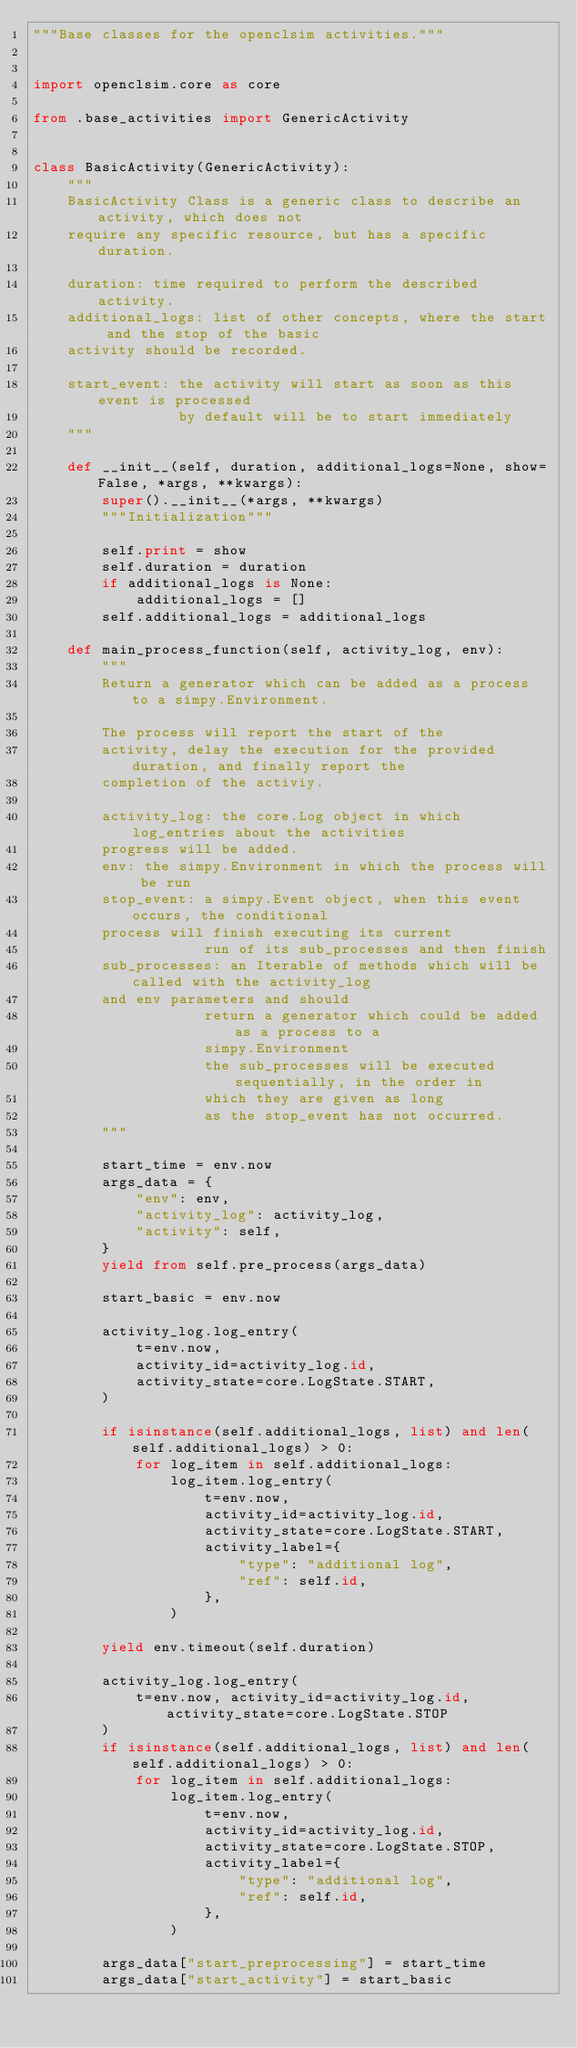Convert code to text. <code><loc_0><loc_0><loc_500><loc_500><_Python_>"""Base classes for the openclsim activities."""


import openclsim.core as core

from .base_activities import GenericActivity


class BasicActivity(GenericActivity):
    """
    BasicActivity Class is a generic class to describe an activity, which does not
    require any specific resource, but has a specific duration.

    duration: time required to perform the described activity.
    additional_logs: list of other concepts, where the start and the stop of the basic
    activity should be recorded.

    start_event: the activity will start as soon as this event is processed
                 by default will be to start immediately
    """

    def __init__(self, duration, additional_logs=None, show=False, *args, **kwargs):
        super().__init__(*args, **kwargs)
        """Initialization"""

        self.print = show
        self.duration = duration
        if additional_logs is None:
            additional_logs = []
        self.additional_logs = additional_logs

    def main_process_function(self, activity_log, env):
        """
        Return a generator which can be added as a process to a simpy.Environment.

        The process will report the start of the
        activity, delay the execution for the provided duration, and finally report the
        completion of the activiy.

        activity_log: the core.Log object in which log_entries about the activities
        progress will be added.
        env: the simpy.Environment in which the process will be run
        stop_event: a simpy.Event object, when this event occurs, the conditional
        process will finish executing its current
                    run of its sub_processes and then finish
        sub_processes: an Iterable of methods which will be called with the activity_log
        and env parameters and should
                    return a generator which could be added as a process to a
                    simpy.Environment
                    the sub_processes will be executed sequentially, in the order in
                    which they are given as long
                    as the stop_event has not occurred.
        """

        start_time = env.now
        args_data = {
            "env": env,
            "activity_log": activity_log,
            "activity": self,
        }
        yield from self.pre_process(args_data)

        start_basic = env.now

        activity_log.log_entry(
            t=env.now,
            activity_id=activity_log.id,
            activity_state=core.LogState.START,
        )

        if isinstance(self.additional_logs, list) and len(self.additional_logs) > 0:
            for log_item in self.additional_logs:
                log_item.log_entry(
                    t=env.now,
                    activity_id=activity_log.id,
                    activity_state=core.LogState.START,
                    activity_label={
                        "type": "additional log",
                        "ref": self.id,
                    },
                )

        yield env.timeout(self.duration)

        activity_log.log_entry(
            t=env.now, activity_id=activity_log.id, activity_state=core.LogState.STOP
        )
        if isinstance(self.additional_logs, list) and len(self.additional_logs) > 0:
            for log_item in self.additional_logs:
                log_item.log_entry(
                    t=env.now,
                    activity_id=activity_log.id,
                    activity_state=core.LogState.STOP,
                    activity_label={
                        "type": "additional log",
                        "ref": self.id,
                    },
                )

        args_data["start_preprocessing"] = start_time
        args_data["start_activity"] = start_basic</code> 